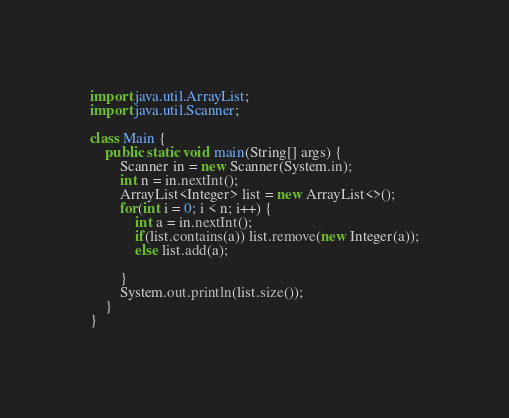Convert code to text. <code><loc_0><loc_0><loc_500><loc_500><_Java_>import java.util.ArrayList;
import java.util.Scanner;

class Main {
    public static void main(String[] args) {
        Scanner in = new Scanner(System.in);
        int n = in.nextInt();
        ArrayList<Integer> list = new ArrayList<>();
        for(int i = 0; i < n; i++) {
            int a = in.nextInt();
            if(list.contains(a)) list.remove(new Integer(a));
            else list.add(a);
            
        }
        System.out.println(list.size());
    }
}
</code> 